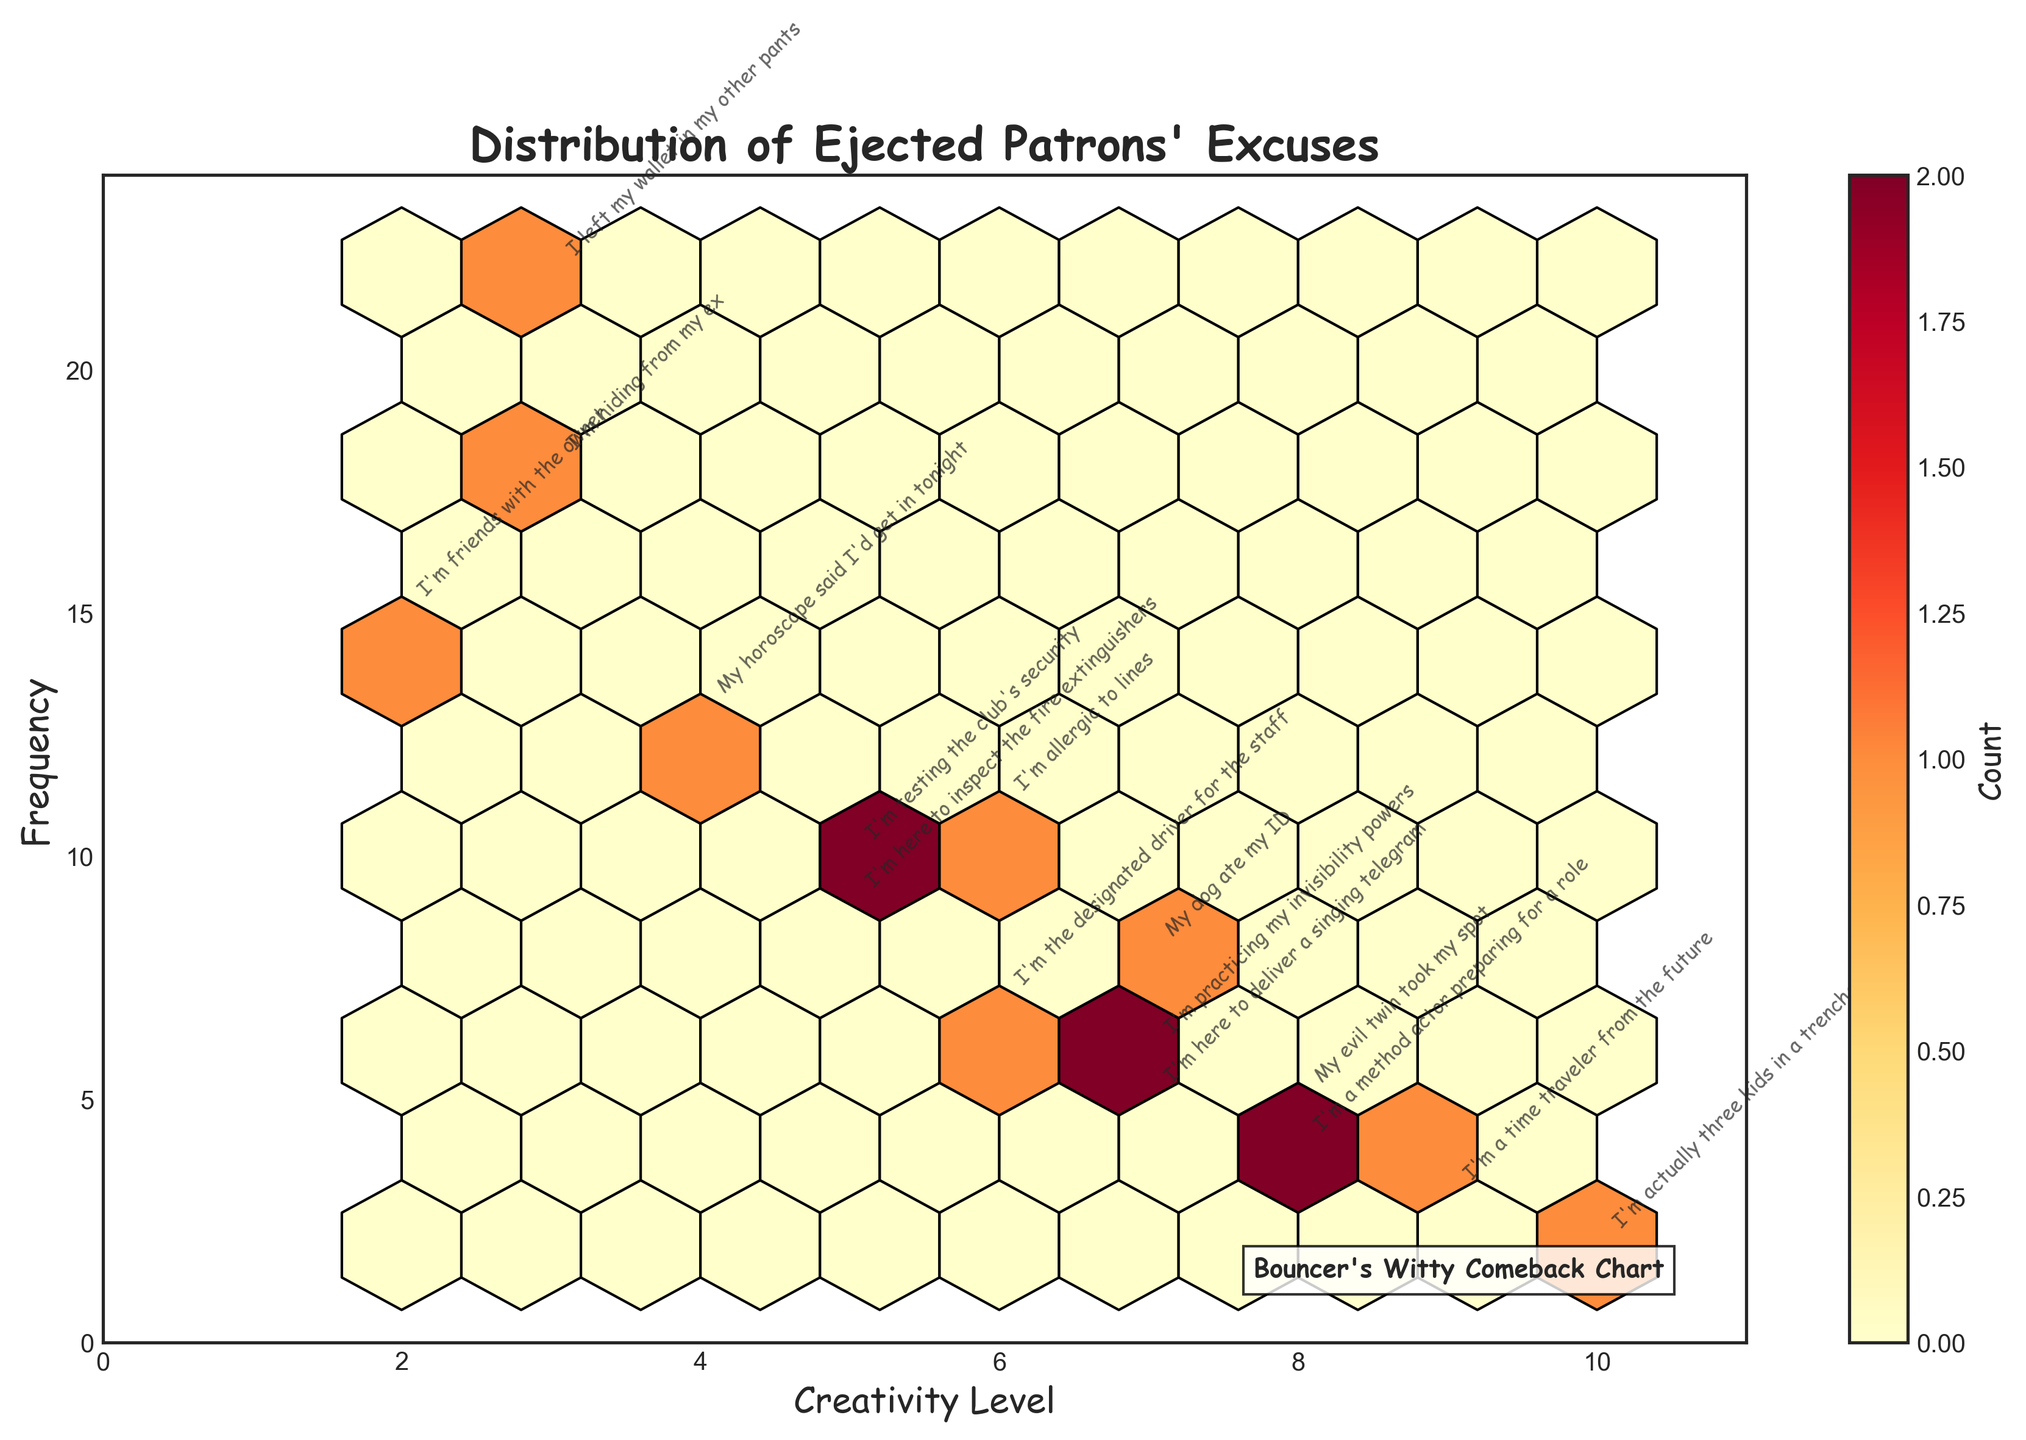What's the title of the figure? The title is usually at the top of the plot. Here, it reads "Distribution of Ejected Patrons' Excuses".
Answer: Distribution of Ejected Patrons' Excuses What's on the x-axis? The x-axis label is found below the horizontal axis, which here is labeled as "Creativity Level".
Answer: Creativity Level How many excuses have a creativity level greater than 7? Check each data point's creativity level and count those above 7. Specifically, they are: "I'm a time traveler from the future", "I'm actually three kids in a trenchcoat", "My evil twin took my spot", and "I'm a method actor preparing for a role".
Answer: 4 Which excuse has the highest creativity level and what is its frequency? Locate the excuse with the highest creativity level which is "I'm actually three kids in a trenchcoat" with a creativity level of 10. Its frequency is at 2.
Answer: "I'm actually three kids in a trenchcoat", 2 What's the frequency range of the excuses? Check the minimum and maximum values on the y-axis. The range is from 2 to 22.
Answer: 2 to 22 Which excuse has the highest frequency? Look for the tallest bar in the figure. "I left my wallet in my other pants" has the highest frequency of 22.
Answer: "I left my wallet in my other pants" Is there an excuse that has a creativity level of 5? If yes, how many times is it used? Locate the point where the creativity level is 5. The excuses "I'm here to inspect the fire extinguishers" and "I'm testing the club's security" fall in this category with frequencies of 9 and 10 respectively.
Answer: Yes, 9 and 10 How many excuses have a creativity level equal to or below 3? Examine the data points with creativity levels of 3 or less. They are: "I'm friends with the owner", "I left my wallet in my other pants", and "I'm hiding from my ex".
Answer: 3 What is the color scheme used in the Hexbin plot? The color scheme can be observed in the plot, which here is "YlOrRd" (shades of yellow to red).
Answer: YlOrRd What information does the color bar on the right indicate? The color bar shows the count of data points in each hexbin as indicated by the label "Count" next to the color bar.
Answer: Count 